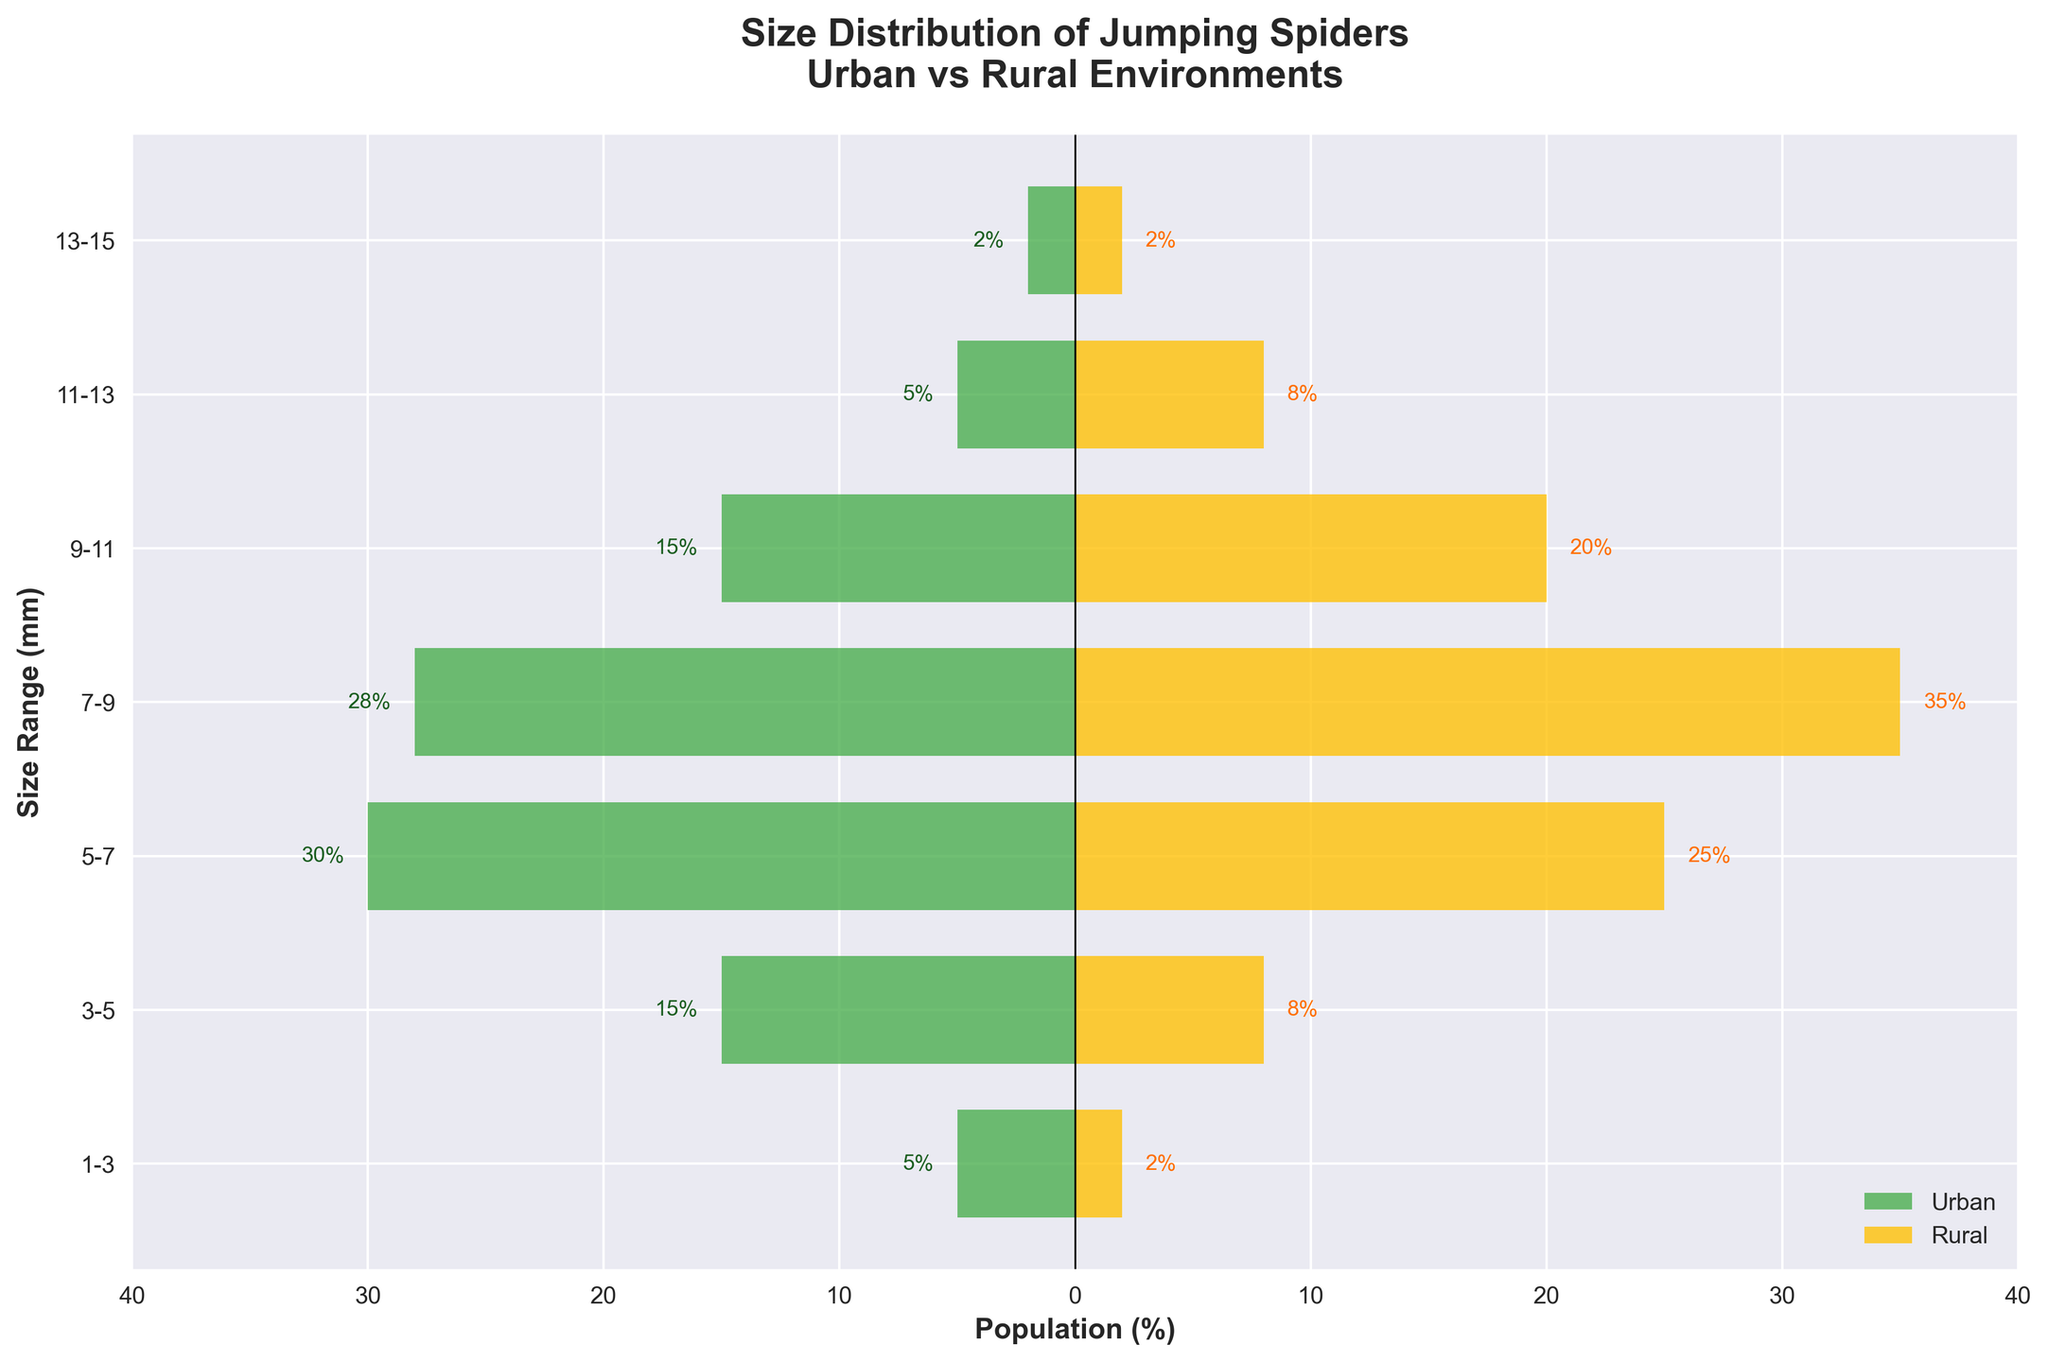Which environment has a higher population percentage of jumping spiders in the 7-9mm size range? From the figure, the bar for the rural population in the 7-9mm size range is longer than the urban population bar. By checking the values, the rural population is 35%, and the urban population is 28%. Therefore, the rural environment has a higher population percentage.
Answer: Rural What's the total percentage of jumping spiders in the urban environment for sizes 5-9mm? The 5-7mm range has 30%, and the 7-9mm range has 28%. The total percentage is 30% + 28% = 58%.
Answer: 58% How many size ranges show a higher population percentage in rural areas compared to urban areas? Comparing the bars for each size range: 3-5mm, 7-9mm, 9-11mm, and 11-13mm have higher rural population percentages, making it 4 size ranges in total.
Answer: 4 In which size range do urban and rural populations have the same percentage? From the figure, the bars for the 13-15mm size range are equal in length for both urban and rural populations, each standing at 2%.
Answer: 13-15mm For which size range does the urban population have the largest percentage difference from the rural population? By comparing the absolute differences, 3-5mm has a difference of 7% (15% urban, 8% rural), while others have smaller differences. Therefore, the largest difference is found in the 3-5mm range.
Answer: 3-5mm What's the average percentage of jumping spiders across all size ranges in the rural environment? Adding all rural percentages: 2% + 8% + 25% + 35% + 20% + 8% + 2% = 100%. There are 7 size ranges, so the average is 100% / 7 ≈ 14.29%.
Answer: 14.29% Which environment has a higher percentage of larger jumping spiders (9-15mm)? Summing up percentages for 9-11mm, 11-13mm, and 13-15mm sizes: Urban: 15% + 5% + 2% = 22%; Rural: 20% + 8% + 2% = 30%. The rural environment has a higher percentage of larger jumping spiders.
Answer: Rural 